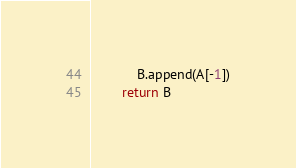Convert code to text. <code><loc_0><loc_0><loc_500><loc_500><_Python_>	        B.append(A[-1])
	    return B
</code> 